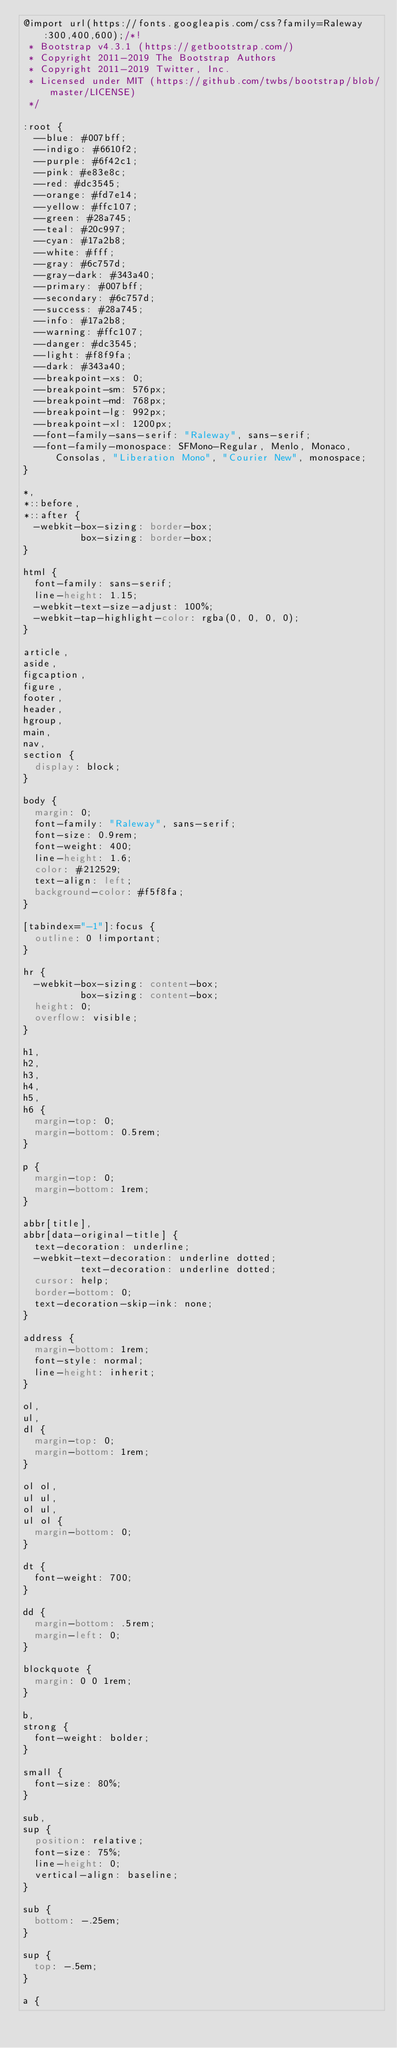Convert code to text. <code><loc_0><loc_0><loc_500><loc_500><_CSS_>@import url(https://fonts.googleapis.com/css?family=Raleway:300,400,600);/*!
 * Bootstrap v4.3.1 (https://getbootstrap.com/)
 * Copyright 2011-2019 The Bootstrap Authors
 * Copyright 2011-2019 Twitter, Inc.
 * Licensed under MIT (https://github.com/twbs/bootstrap/blob/master/LICENSE)
 */

:root {
  --blue: #007bff;
  --indigo: #6610f2;
  --purple: #6f42c1;
  --pink: #e83e8c;
  --red: #dc3545;
  --orange: #fd7e14;
  --yellow: #ffc107;
  --green: #28a745;
  --teal: #20c997;
  --cyan: #17a2b8;
  --white: #fff;
  --gray: #6c757d;
  --gray-dark: #343a40;
  --primary: #007bff;
  --secondary: #6c757d;
  --success: #28a745;
  --info: #17a2b8;
  --warning: #ffc107;
  --danger: #dc3545;
  --light: #f8f9fa;
  --dark: #343a40;
  --breakpoint-xs: 0;
  --breakpoint-sm: 576px;
  --breakpoint-md: 768px;
  --breakpoint-lg: 992px;
  --breakpoint-xl: 1200px;
  --font-family-sans-serif: "Raleway", sans-serif;
  --font-family-monospace: SFMono-Regular, Menlo, Monaco, Consolas, "Liberation Mono", "Courier New", monospace;
}

*,
*::before,
*::after {
  -webkit-box-sizing: border-box;
          box-sizing: border-box;
}

html {
  font-family: sans-serif;
  line-height: 1.15;
  -webkit-text-size-adjust: 100%;
  -webkit-tap-highlight-color: rgba(0, 0, 0, 0);
}

article,
aside,
figcaption,
figure,
footer,
header,
hgroup,
main,
nav,
section {
  display: block;
}

body {
  margin: 0;
  font-family: "Raleway", sans-serif;
  font-size: 0.9rem;
  font-weight: 400;
  line-height: 1.6;
  color: #212529;
  text-align: left;
  background-color: #f5f8fa;
}

[tabindex="-1"]:focus {
  outline: 0 !important;
}

hr {
  -webkit-box-sizing: content-box;
          box-sizing: content-box;
  height: 0;
  overflow: visible;
}

h1,
h2,
h3,
h4,
h5,
h6 {
  margin-top: 0;
  margin-bottom: 0.5rem;
}

p {
  margin-top: 0;
  margin-bottom: 1rem;
}

abbr[title],
abbr[data-original-title] {
  text-decoration: underline;
  -webkit-text-decoration: underline dotted;
          text-decoration: underline dotted;
  cursor: help;
  border-bottom: 0;
  text-decoration-skip-ink: none;
}

address {
  margin-bottom: 1rem;
  font-style: normal;
  line-height: inherit;
}

ol,
ul,
dl {
  margin-top: 0;
  margin-bottom: 1rem;
}

ol ol,
ul ul,
ol ul,
ul ol {
  margin-bottom: 0;
}

dt {
  font-weight: 700;
}

dd {
  margin-bottom: .5rem;
  margin-left: 0;
}

blockquote {
  margin: 0 0 1rem;
}

b,
strong {
  font-weight: bolder;
}

small {
  font-size: 80%;
}

sub,
sup {
  position: relative;
  font-size: 75%;
  line-height: 0;
  vertical-align: baseline;
}

sub {
  bottom: -.25em;
}

sup {
  top: -.5em;
}

a {</code> 